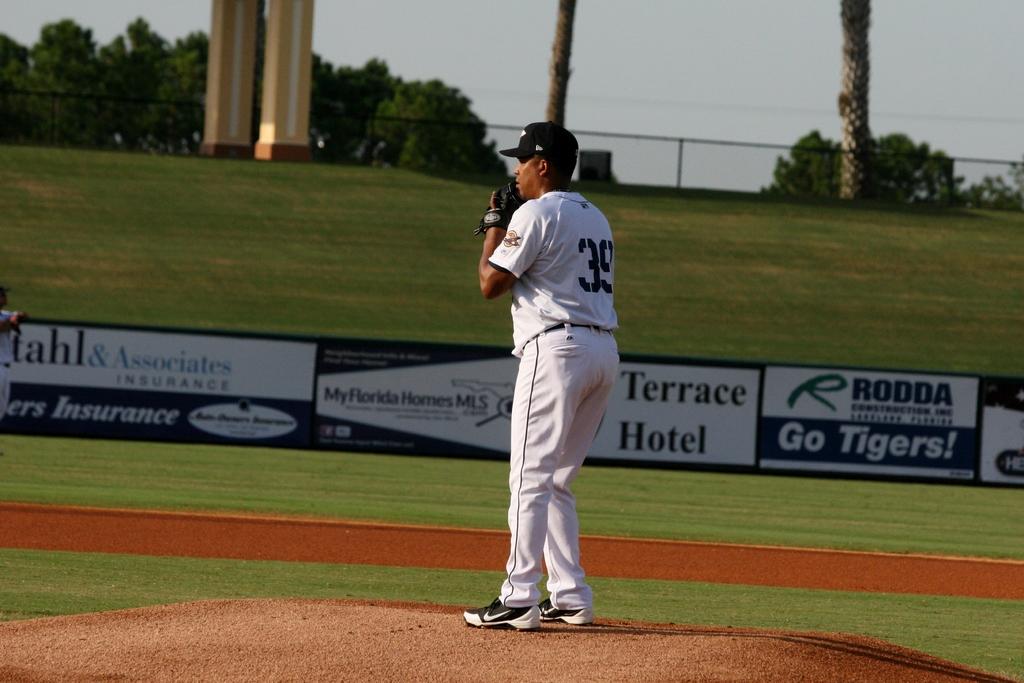What hotel sponsors this field?
Make the answer very short. Terrace. 